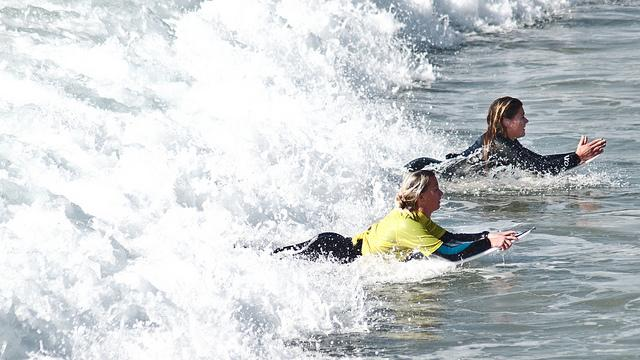What should one be good at before one begins to learn this sport? Please explain your reasoning. swimming. People need to swim to surf. 